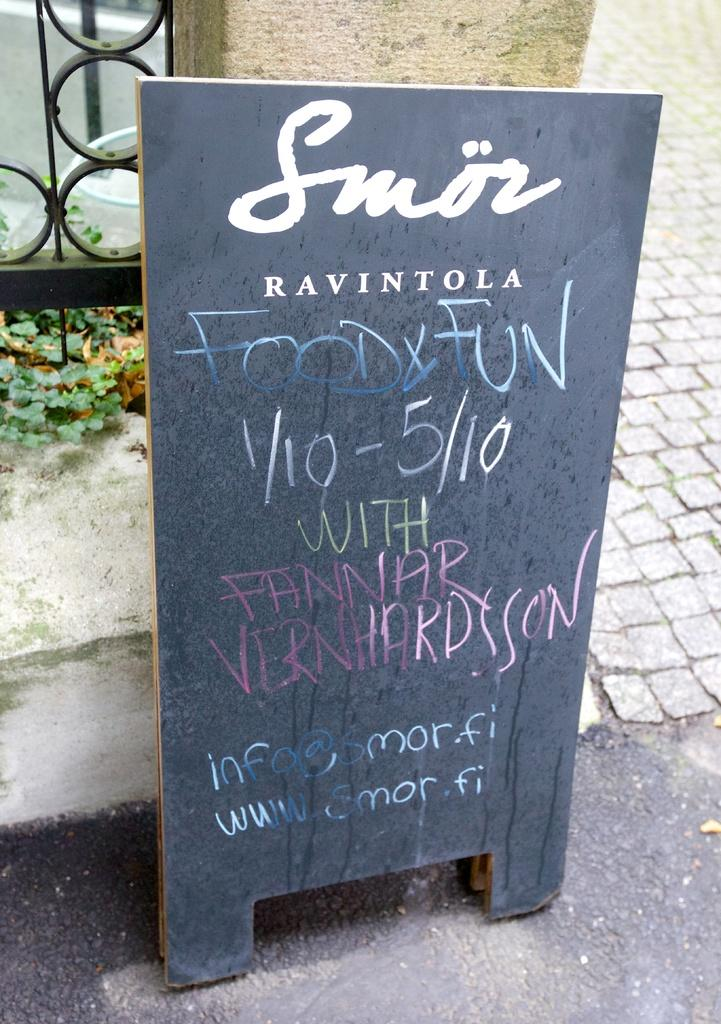What is the main object in the image? There is a blackboard in the image. What is written on the blackboard? The blackboard has a food menu on it. What can be seen in the background of the image? There is fencing, plants, and a walkway in the background of the image. How many trucks are parked near the blackboard in the image? There are no trucks mentioned or visible in the image. Can you tell me what type of animals are present in the zoo in the image? There is no mention of a zoo or any animals in the image. 